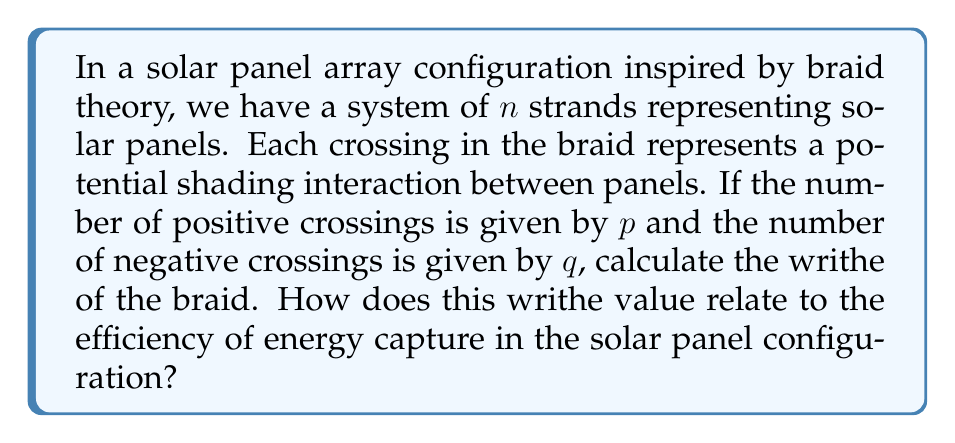Help me with this question. To solve this problem, we'll follow these steps:

1) In braid theory, the writhe of a braid is defined as the difference between the number of positive crossings and negative crossings. Mathematically, this is expressed as:

   $$W = p - q$$

   Where $W$ is the writhe, $p$ is the number of positive crossings, and $q$ is the number of negative crossings.

2) In the context of solar panel configurations, positive crossings might represent panels that are optimally positioned to avoid shading each other, while negative crossings could represent suboptimal positioning that leads to shading.

3) A higher positive writhe value would indicate a configuration with more optimal crossings, potentially leading to better energy capture efficiency.

4) Conversely, a negative writhe value would suggest a configuration with more suboptimal crossings, potentially reducing energy capture efficiency.

5) A writhe value of zero would indicate an equal number of positive and negative crossings, suggesting a neutral configuration in terms of shading effects.

6) In practice, solar panel designers would aim to maximize the writhe value, as this would correspond to a configuration with more positive crossings (optimal positioning) than negative crossings (suboptimal positioning).

7) The relationship between writhe and efficiency is not necessarily linear, as other factors (such as panel tilt, geographical location, and time of day) also play crucial roles in determining overall energy capture efficiency.
Answer: $W = p - q$; Higher writhe suggests higher efficiency. 